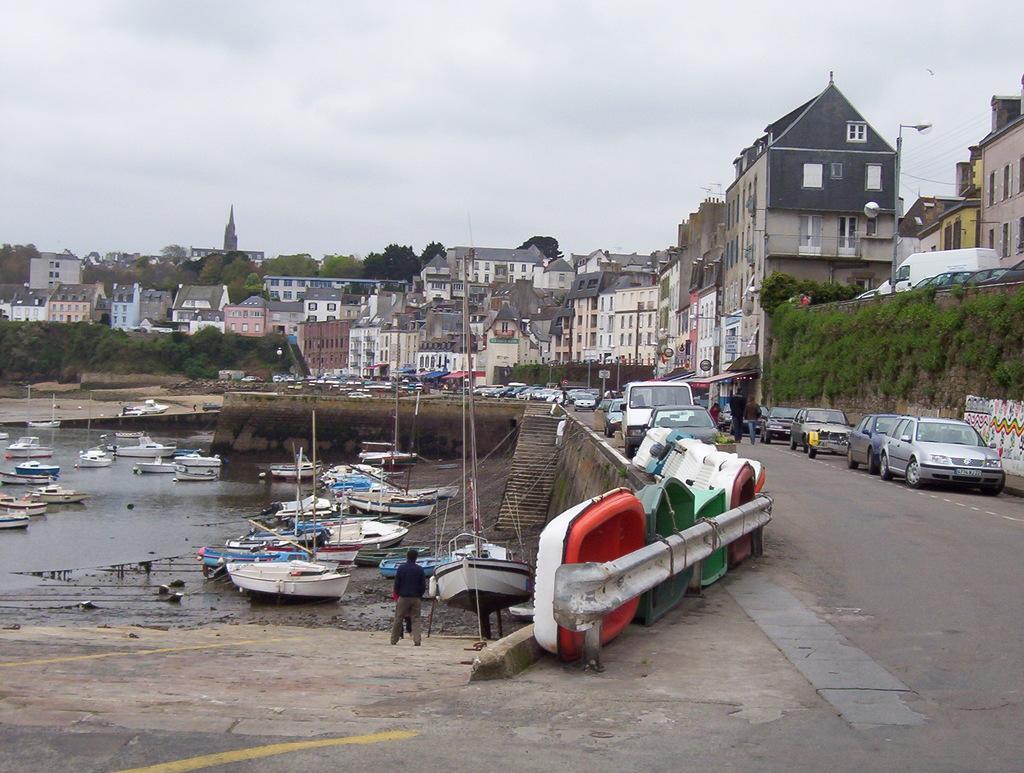In one or two sentences, can you explain what this image depicts? In this picture we can observe a fleet on the water. There are some boats on the road behind this railing. We can observe some cars on the side of this road. There are some plants on the wall. There is some water here. We can observe a person standing. In the background there are trees, buildings and a sky. 